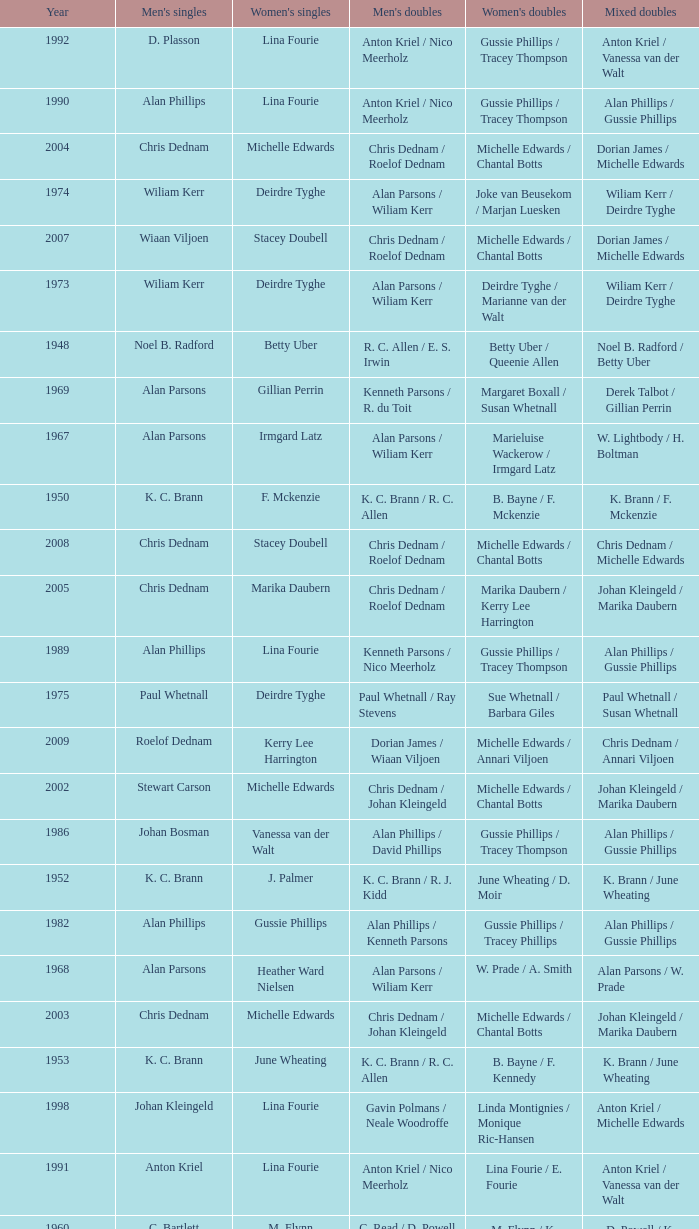Which Men's doubles have a Year smaller than 1960, and Men's singles of noel b. radford? R. C. Allen / E. S. Irwin. 